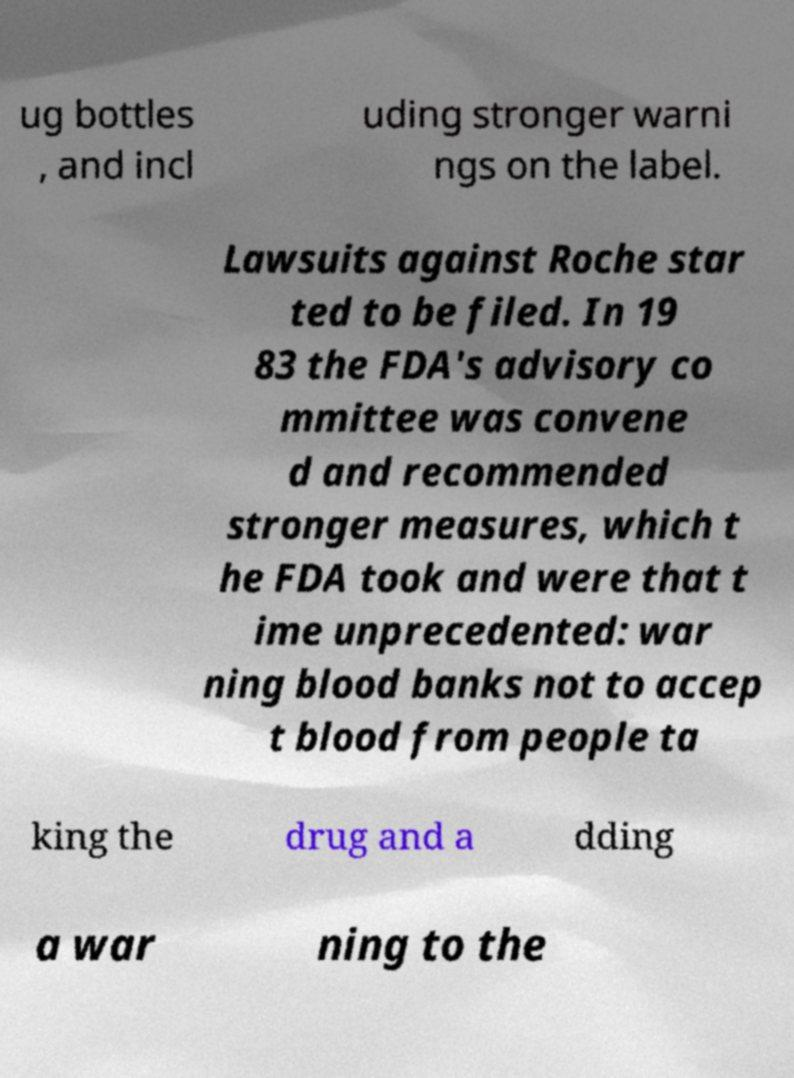Could you assist in decoding the text presented in this image and type it out clearly? ug bottles , and incl uding stronger warni ngs on the label. Lawsuits against Roche star ted to be filed. In 19 83 the FDA's advisory co mmittee was convene d and recommended stronger measures, which t he FDA took and were that t ime unprecedented: war ning blood banks not to accep t blood from people ta king the drug and a dding a war ning to the 